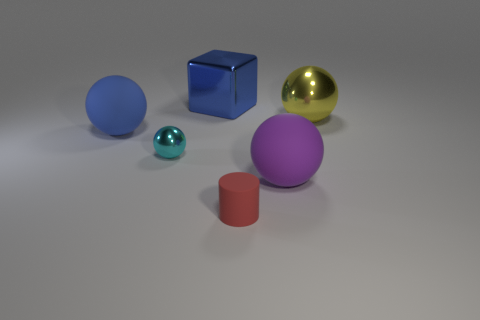What is the color of the large metallic ball?
Offer a terse response. Yellow. What shape is the big matte object that is the same color as the big cube?
Keep it short and to the point. Sphere. Are there any big gray cylinders?
Your answer should be very brief. No. The red cylinder that is the same material as the purple ball is what size?
Offer a very short reply. Small. There is a tiny object to the right of the big blue thing to the right of the big rubber ball that is behind the purple matte thing; what shape is it?
Provide a short and direct response. Cylinder. Are there an equal number of yellow metallic spheres in front of the large yellow thing and yellow metal balls?
Your answer should be very brief. No. What is the size of the object that is the same color as the block?
Offer a very short reply. Large. Do the blue rubber thing and the tiny cyan metal object have the same shape?
Offer a terse response. Yes. What number of objects are objects that are in front of the yellow ball or large yellow shiny cylinders?
Provide a succinct answer. 4. Are there an equal number of tiny cyan metal things that are in front of the small cylinder and purple matte objects behind the big yellow shiny sphere?
Keep it short and to the point. Yes. 